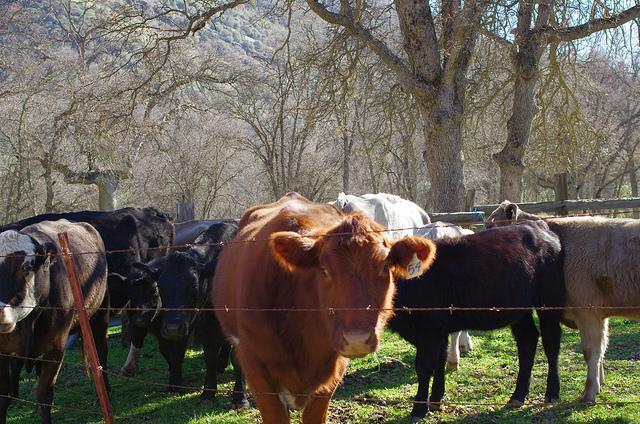How many cows are in the picture?
Give a very brief answer. 8. 